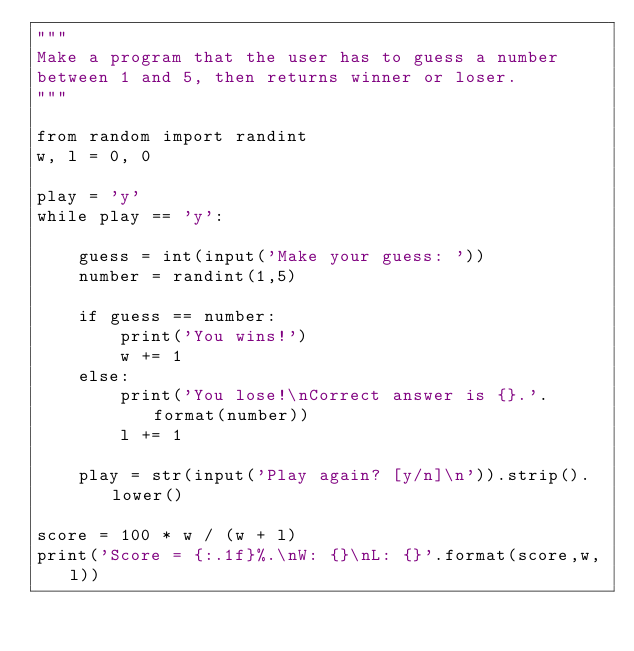Convert code to text. <code><loc_0><loc_0><loc_500><loc_500><_Python_>"""
Make a program that the user has to guess a number
between 1 and 5, then returns winner or loser.
"""

from random import randint
w, l = 0, 0

play = 'y'
while play == 'y':

    guess = int(input('Make your guess: '))
    number = randint(1,5)

    if guess == number:
        print('You wins!')
        w += 1
    else:
        print('You lose!\nCorrect answer is {}.'.format(number))
        l += 1

    play = str(input('Play again? [y/n]\n')).strip().lower()

score = 100 * w / (w + l)
print('Score = {:.1f}%.\nW: {}\nL: {}'.format(score,w,l))
</code> 